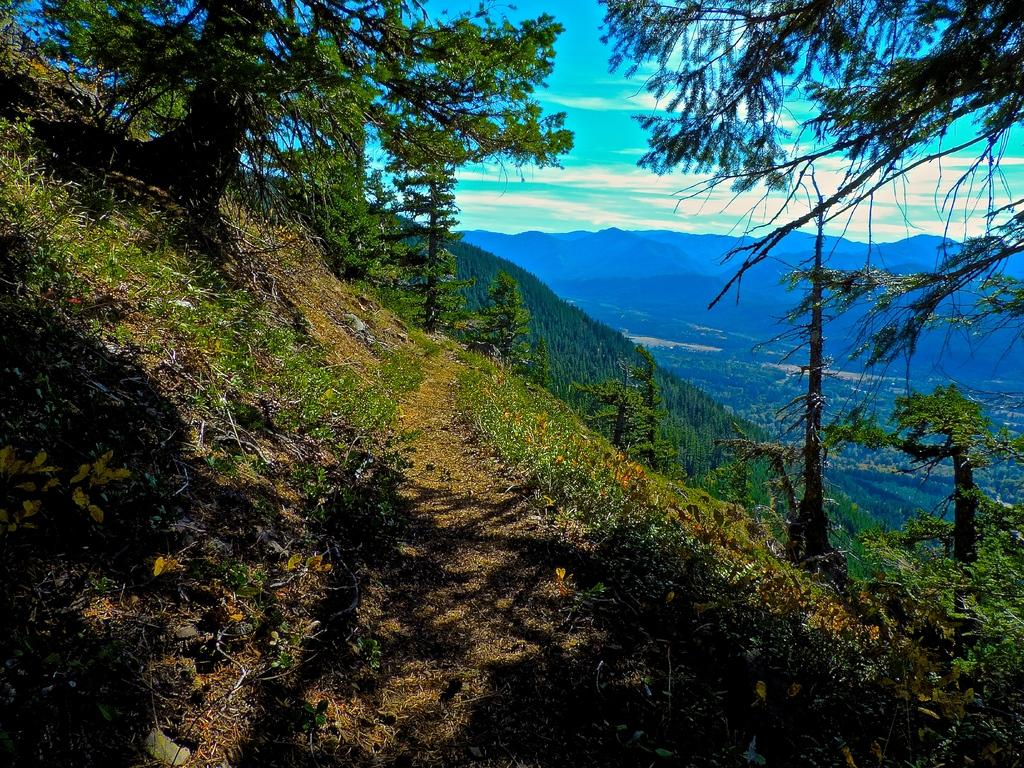What is the main feature in the image? There is a fountain in the image. What is unique about this fountain? The fountain is filled with grass. What other natural elements can be seen in the image? There are trees in the image. What is visible in the background of the image? There is a mountain in the background, and there are other hills behind the mountain. What part of the sky is visible in the image? The sky is visible in the background. What type of linen is draped over the mountain in the image? There is no linen present in the image; the mountain is not draped with any fabric. Can you describe the fog surrounding the trees in the image? There is no fog present in the image; the trees are clearly visible. 